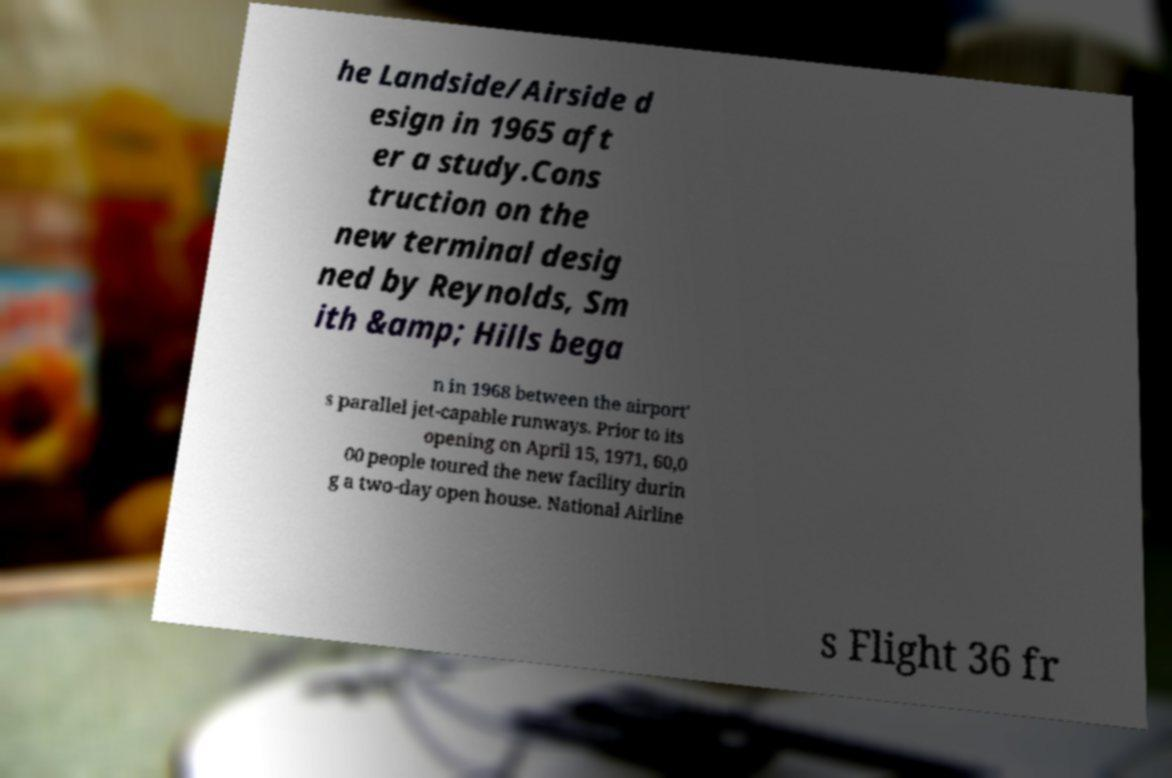Please identify and transcribe the text found in this image. he Landside/Airside d esign in 1965 aft er a study.Cons truction on the new terminal desig ned by Reynolds, Sm ith &amp; Hills bega n in 1968 between the airport' s parallel jet-capable runways. Prior to its opening on April 15, 1971, 60,0 00 people toured the new facility durin g a two-day open house. National Airline s Flight 36 fr 